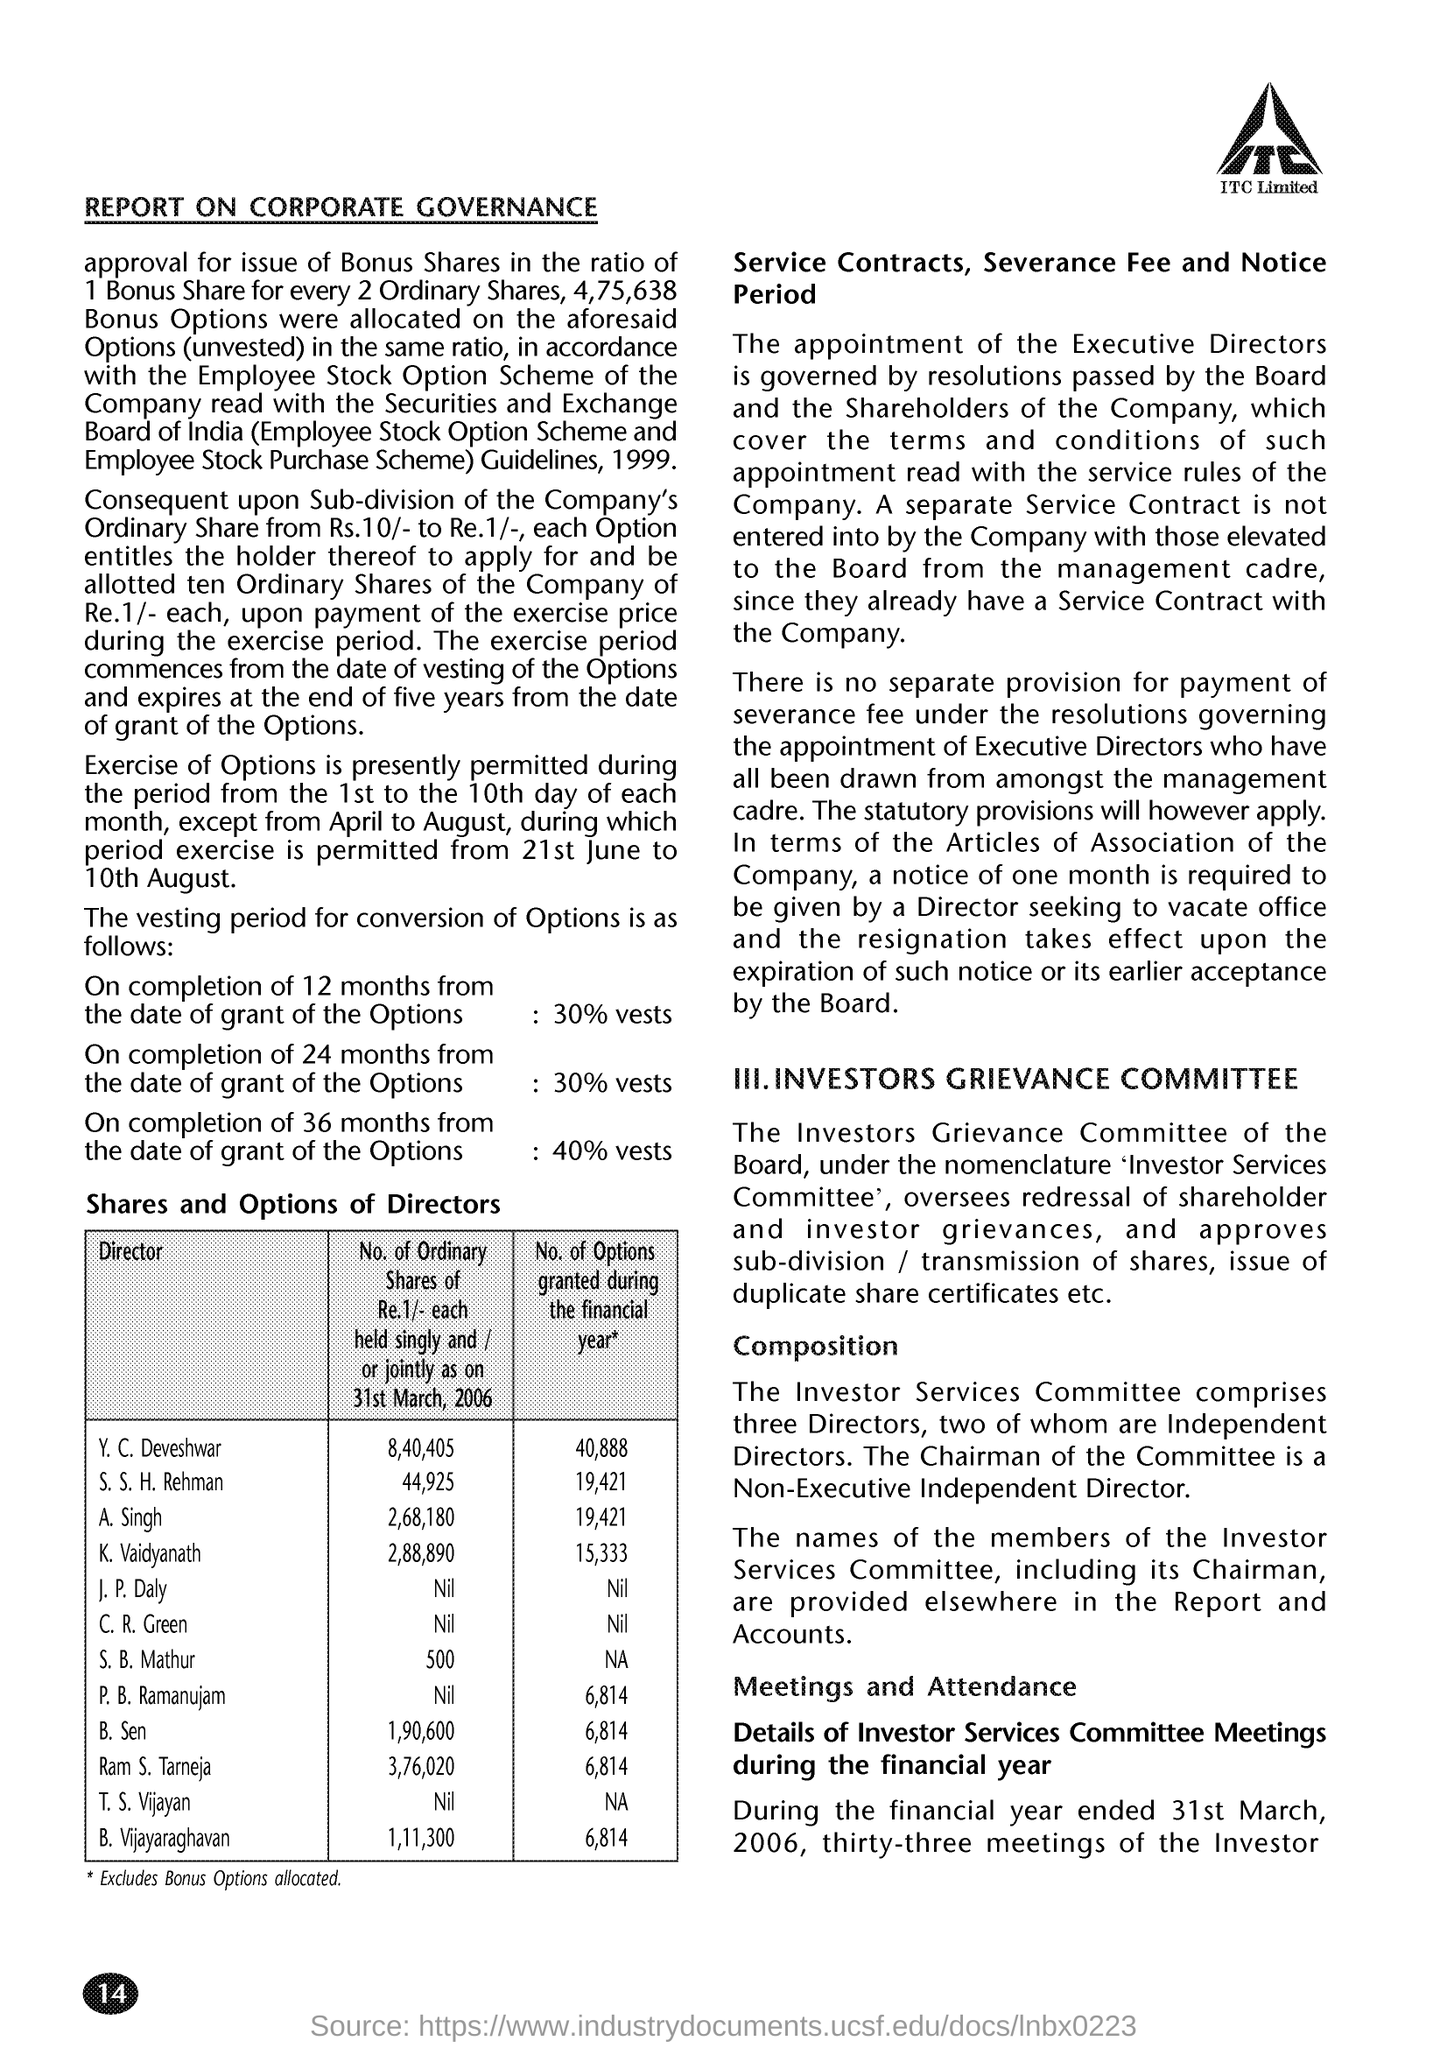Give some essential details in this illustration. The text below the image is 'ITC Limited.'  During the financial year, a maximum of 40,888 options were granted. The director's name is K. Vaidyanath when 15,333 options are granted during the financial year. The page number is 14. The title of the document is "Report on Corporate Governance. 